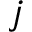<formula> <loc_0><loc_0><loc_500><loc_500>j</formula> 